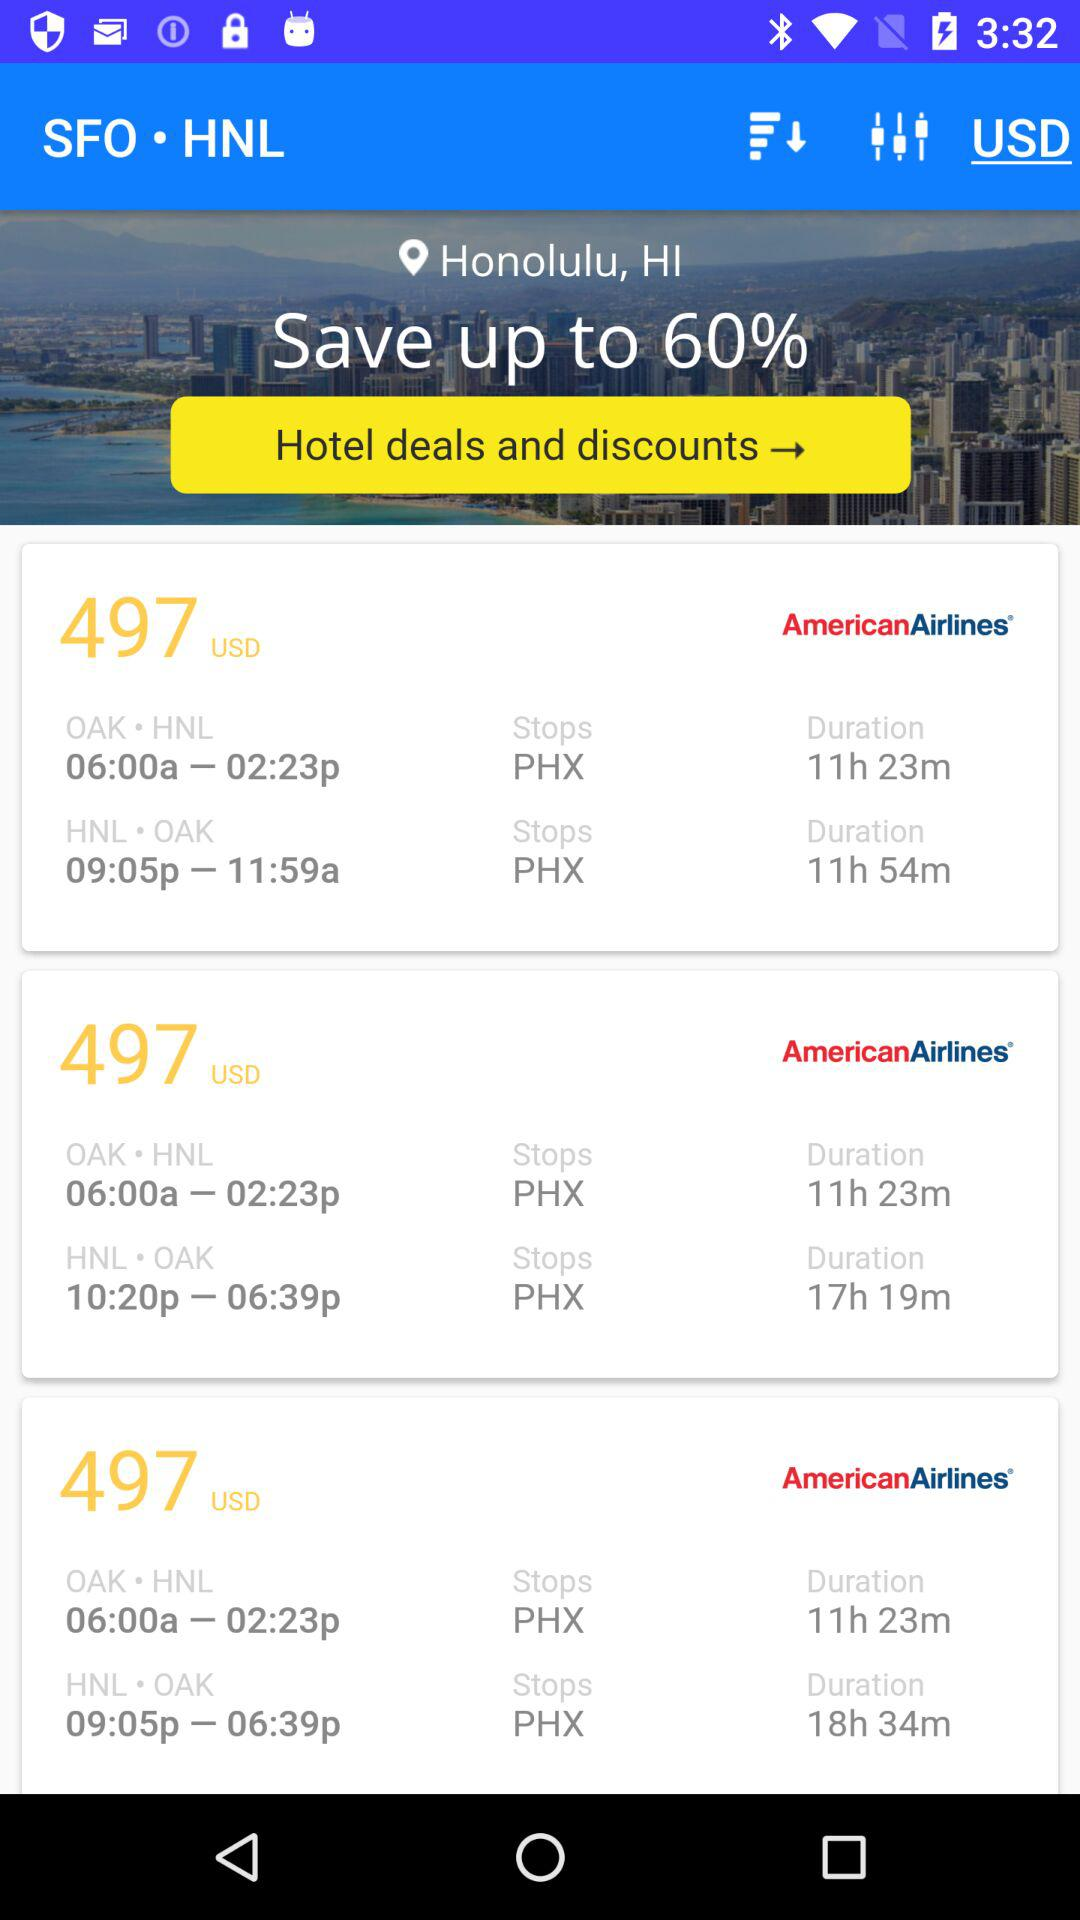What is the pinpoint location? The pinpoint location is Honolulu, HI. 